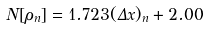<formula> <loc_0><loc_0><loc_500><loc_500>N [ \rho _ { n } ] = 1 . 7 2 3 ( \Delta x ) _ { n } + 2 . 0 0</formula> 